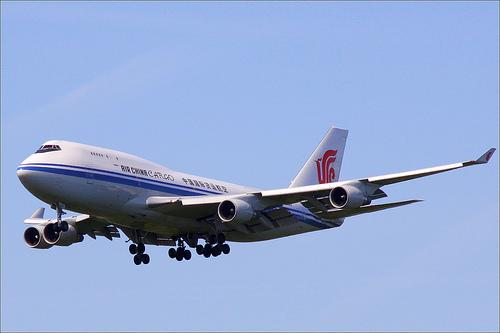Examine the airplane windows and briefly describe the image's portrayal of them. There are cockpit windows where the pilots are situated, and passenger windows along the fuselage's upper half. Assess the quality of the image based on its clarity and composition. The image has high clarity, with fine details evident in the airplane's features, and a balanced composition with the airplane being the main focal point. Count the number of jet engines and propellers on the airplane in the image. The airplane has four jet engines and no propellers. Mention the most noticeable feature of the airplane's wing. The airplane has a distinct winglet on its right wing painted with blue and white stripes. List three distinguishing features of the airplane's tail in the image. The tail has a red Air China logo, Chinese characters on its side, and an insignia of the airline company. What is the most evident sentiment conveyed by the image? The image conveys a sense of strength in flight, showcasing the impressive engineering of the airplane, and the reliability of the airline. Identify the type of airplane in the image and its position in relation to the sky. The image features an Air China Cargo Boeing 747 airplane with wheels down, flying in a clear blue sky. Point out details about the airplane's landing wheels. The airplane landing wheels consist of both nose gear and main gear, visible in the image as extended for landing. Describe the visual elements of the sky in the background. The sky in the background is clear and blue, providing a contrasting backdrop to the airplane. What language is written on the side of the airplane and what does it denote? The writing on the side of the airplane is in Chinese characters, and it most likely denotes the airline's name, "Air China Cargo." 